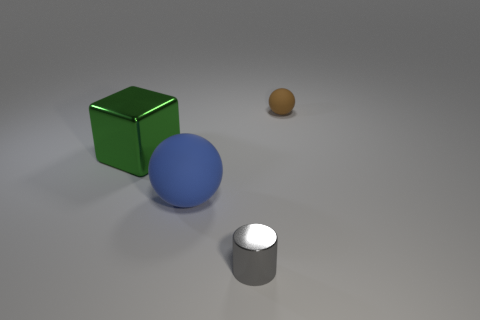Are there any other tiny balls that have the same color as the small rubber sphere?
Your answer should be compact. No. Are any big shiny balls visible?
Your response must be concise. No. Is the size of the matte object in front of the brown rubber ball the same as the small gray thing?
Your response must be concise. No. Are there fewer big matte things than spheres?
Offer a very short reply. Yes. The tiny object that is in front of the tiny object that is to the right of the thing in front of the blue ball is what shape?
Provide a succinct answer. Cylinder. Are there any things made of the same material as the brown ball?
Provide a succinct answer. Yes. Are there fewer small gray shiny cylinders behind the blue sphere than large blue rubber spheres?
Offer a very short reply. Yes. What number of objects are either shiny cubes or metallic things that are behind the small gray thing?
Your response must be concise. 1. There is a small object that is the same material as the large cube; what is its color?
Provide a short and direct response. Gray. What number of things are either large red matte spheres or tiny gray metallic cylinders?
Your response must be concise. 1. 